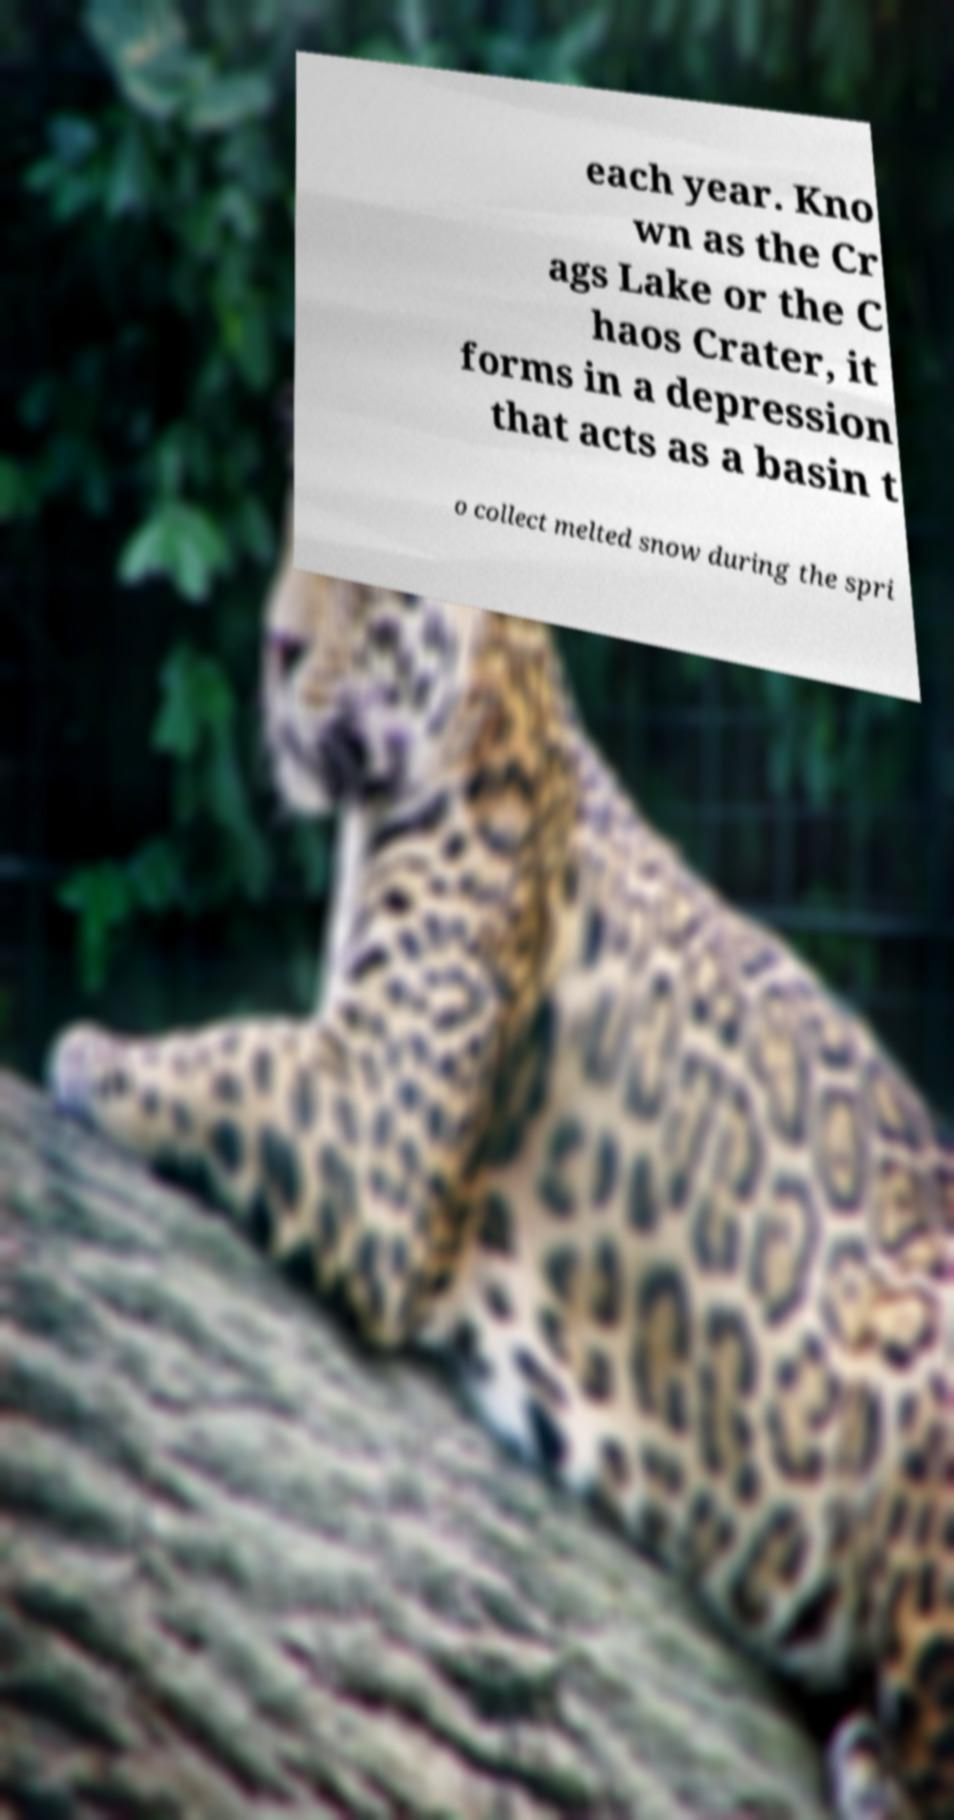Please read and relay the text visible in this image. What does it say? each year. Kno wn as the Cr ags Lake or the C haos Crater, it forms in a depression that acts as a basin t o collect melted snow during the spri 